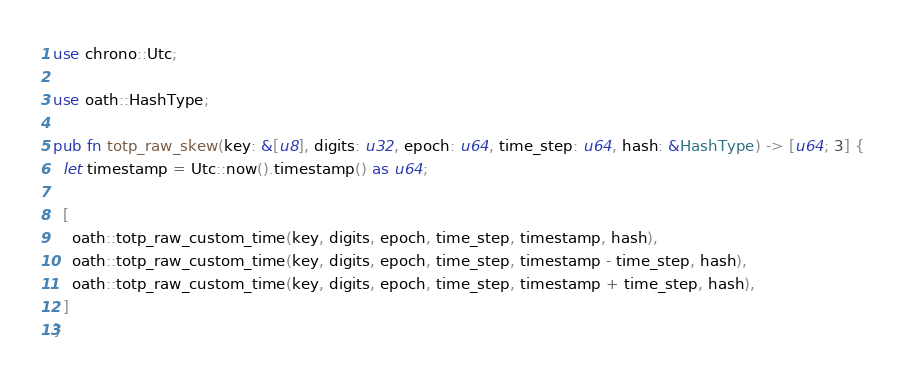<code> <loc_0><loc_0><loc_500><loc_500><_Rust_>use chrono::Utc;

use oath::HashType;

pub fn totp_raw_skew(key: &[u8], digits: u32, epoch: u64, time_step: u64, hash: &HashType) -> [u64; 3] {
  let timestamp = Utc::now().timestamp() as u64;

  [
    oath::totp_raw_custom_time(key, digits, epoch, time_step, timestamp, hash),
    oath::totp_raw_custom_time(key, digits, epoch, time_step, timestamp - time_step, hash),
    oath::totp_raw_custom_time(key, digits, epoch, time_step, timestamp + time_step, hash),
  ]
}
</code> 